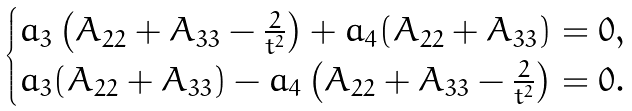Convert formula to latex. <formula><loc_0><loc_0><loc_500><loc_500>\begin{cases} a _ { 3 } \left ( A _ { 2 2 } + A _ { 3 3 } - \frac { 2 } { t ^ { 2 } } \right ) + a _ { 4 } ( A _ { 2 2 } + A _ { 3 3 } ) = 0 , \\ a _ { 3 } ( A _ { 2 2 } + A _ { 3 3 } ) - a _ { 4 } \left ( A _ { 2 2 } + A _ { 3 3 } - \frac { 2 } { t ^ { 2 } } \right ) = 0 . \end{cases}</formula> 